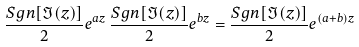<formula> <loc_0><loc_0><loc_500><loc_500>\frac { S g n [ \Im ( z ) ] } { 2 } e ^ { a z } \, \frac { S g n [ \Im ( z ) ] } { 2 } e ^ { b z } = \frac { S g n [ \Im ( z ) ] } { 2 } e ^ { ( a + b ) z }</formula> 